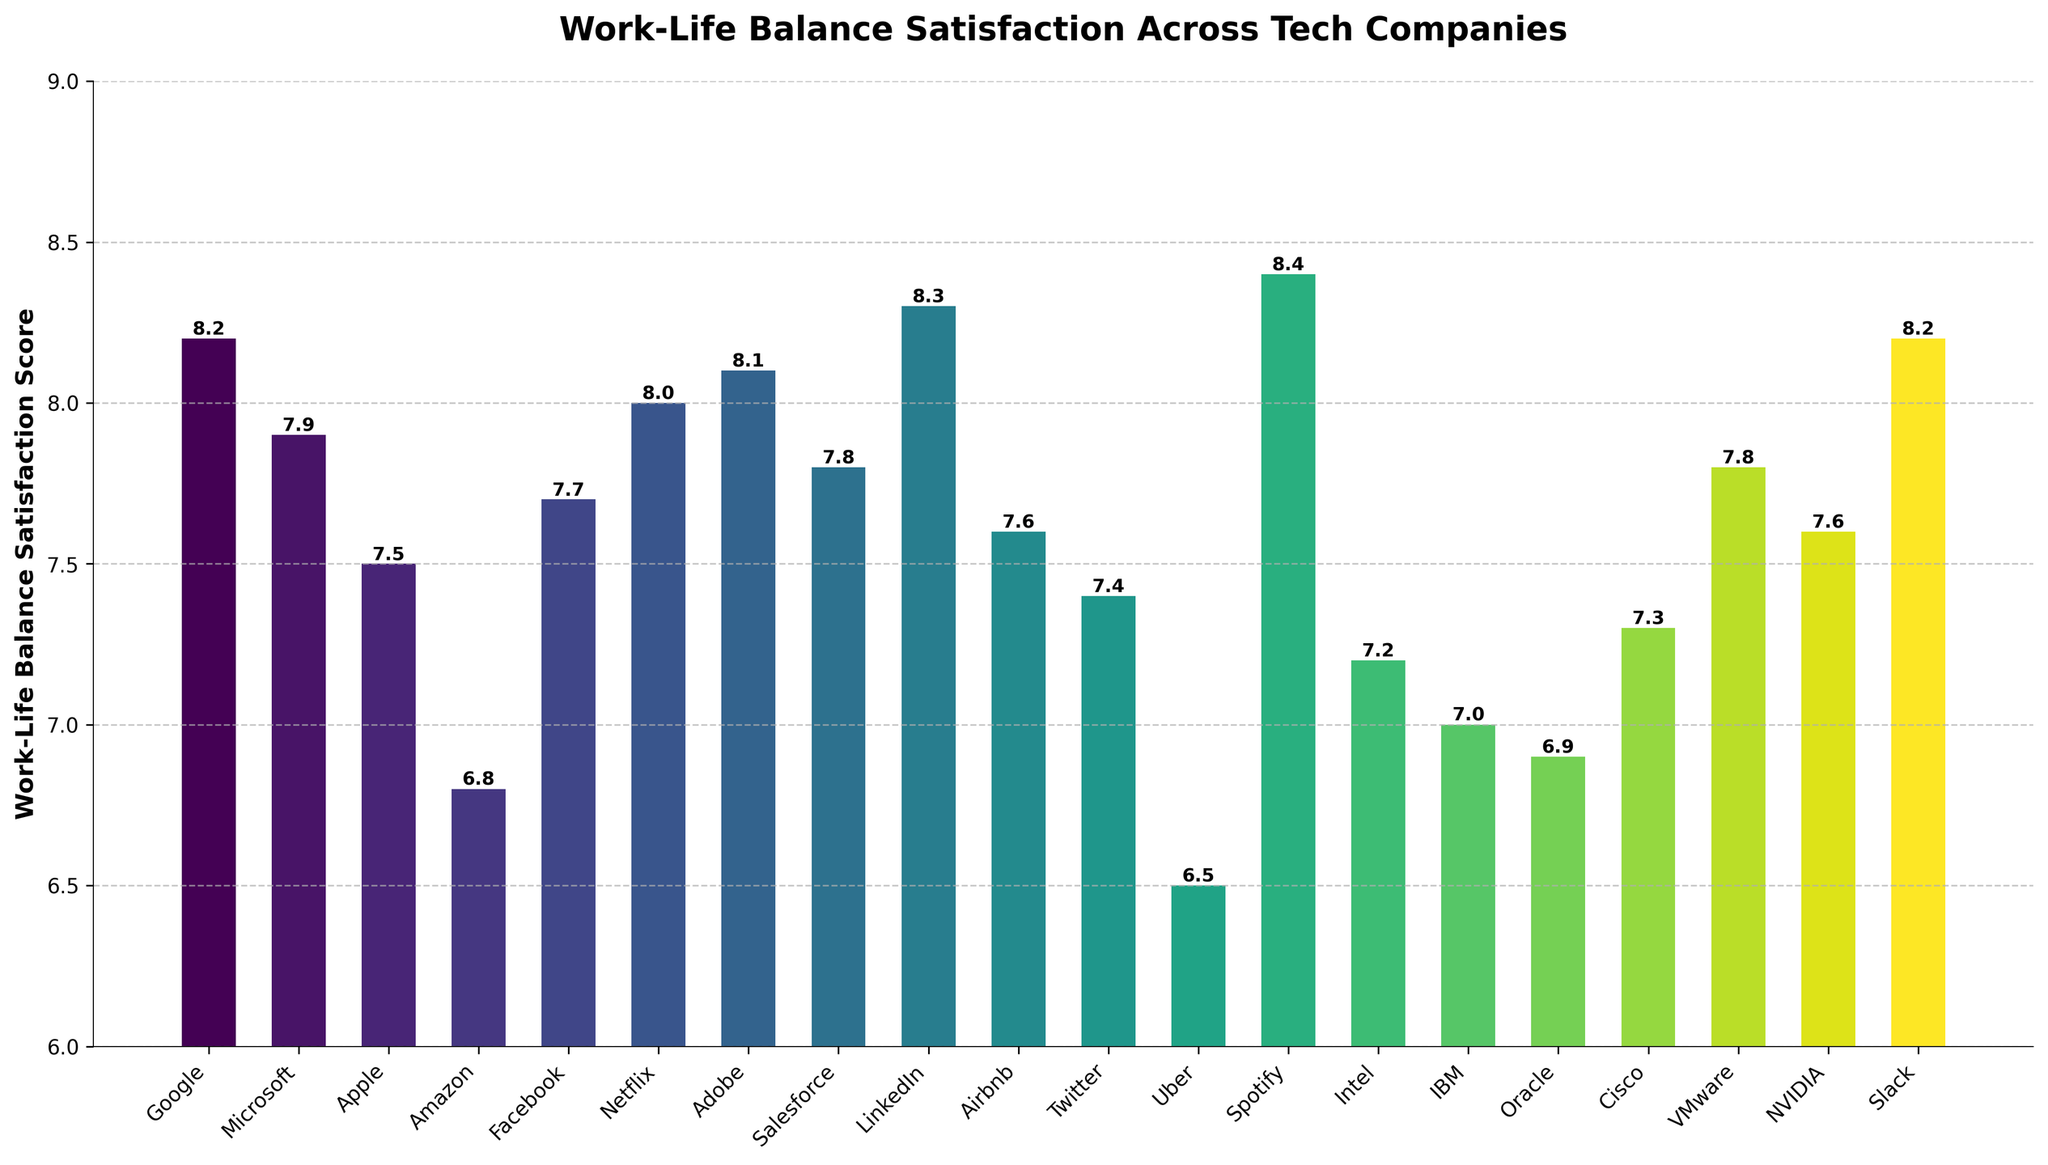what is the difference in work-life balance satisfaction score between Spotify and Amazon? Spotify has a score of 8.4, and Amazon has a score of 6.8. The difference is calculated as 8.4 - 6.8 = 1.6
Answer: 1.6 which tech company has the highest work-life balance satisfaction score? Among the scores, Spotify has the highest work-life balance satisfaction score of 8.4
Answer: Spotify is the work-life balance satisfaction score of Uber above or below the median score of all companies? To find the median, we need to order the scores and find the middle one. Arranged scores: [6.5, 6.8, 6.9, 7.0, 7.2, 7.3, 7.4, 7.5, 7.6, 7.6, 7.7, 7.8, 7.8, 8.0, 8.1, 8.2, 8.2, 8.3, 8.4], the median score is 7.6. Uber’s score is 6.5, which is below 7.6
Answer: below what is the average work-life balance satisfaction score for the companies listed? Adding all the scores and dividing by the number of companies: (8.2 + 7.9 + 7.5 + 6.8 + 7.7 + 8.0 + 8.1 + 7.8 + 8.3 + 7.6 + 7.4 + 6.5 + 8.4 + 7.2 + 7.0 + 6.9 + 7.3 + 7.8 + 7.6 + 8.2)/20 = 7.673
Answer: 7.67 which company has a work-life balance satisfaction score closest to 7.5? Apple has a score of 7.5 which is exactly 7.5, and Airbnb has a score of 7.6 which is closest, but not exact.
Answer: Apple what is the combined work-life balance satisfaction score of Google, Adobe, and Slack? Adding the scores of Google (8.2), Adobe (8.1), and Slack (8.2) together: 8.2 + 8.1 + 8.2 = 24.5
Answer: 24.5 how many companies have a work-life balance satisfaction score above 8.0? The following companies have scores above 8.0: Google (8.2), Adobe (8.1), LinkedIn (8.3), Spotify (8.4), Slack (8.2). So the total count is 5
Answer: 5 is the score for Microsoft greater than, less than, or equal to the score for VMware? Microsoft has a score of 7.9, and VMware also has a score of 7.8. 7.9 is greater than 7.8
Answer: greater than 